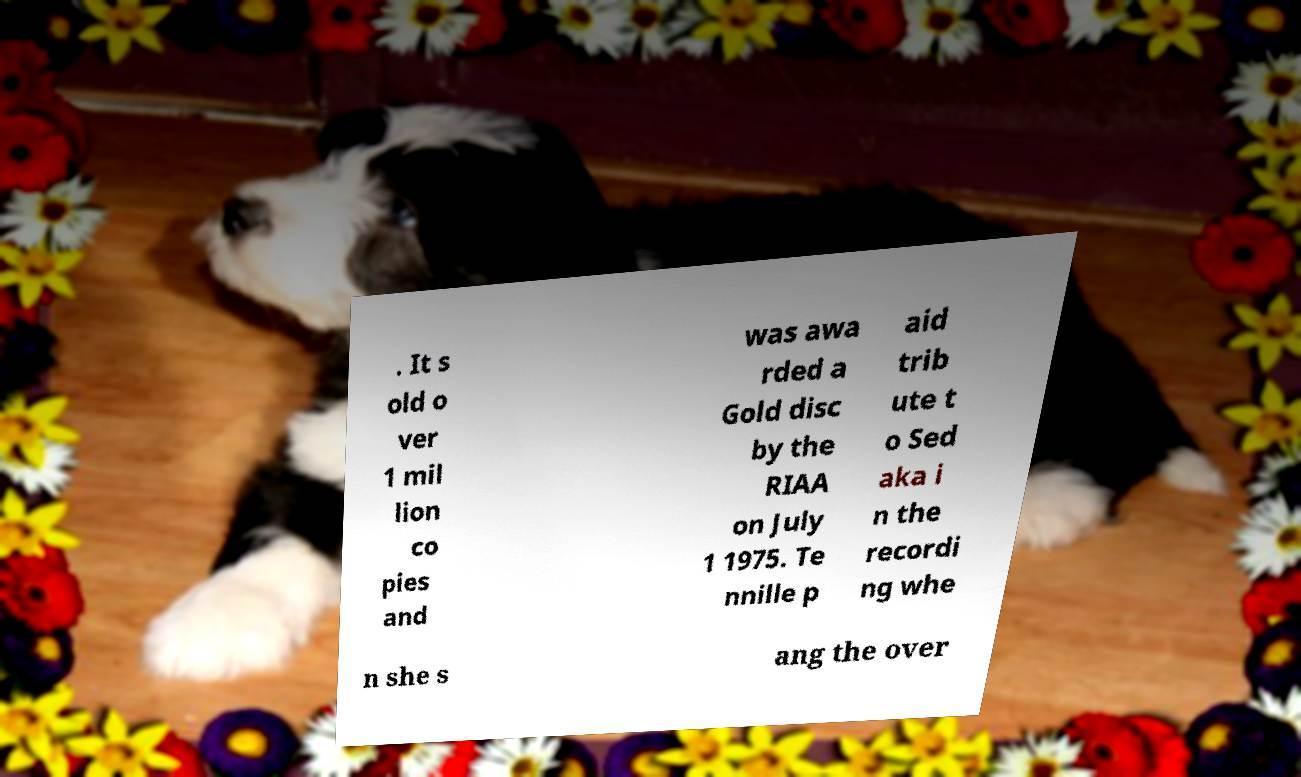What messages or text are displayed in this image? I need them in a readable, typed format. . It s old o ver 1 mil lion co pies and was awa rded a Gold disc by the RIAA on July 1 1975. Te nnille p aid trib ute t o Sed aka i n the recordi ng whe n she s ang the over 